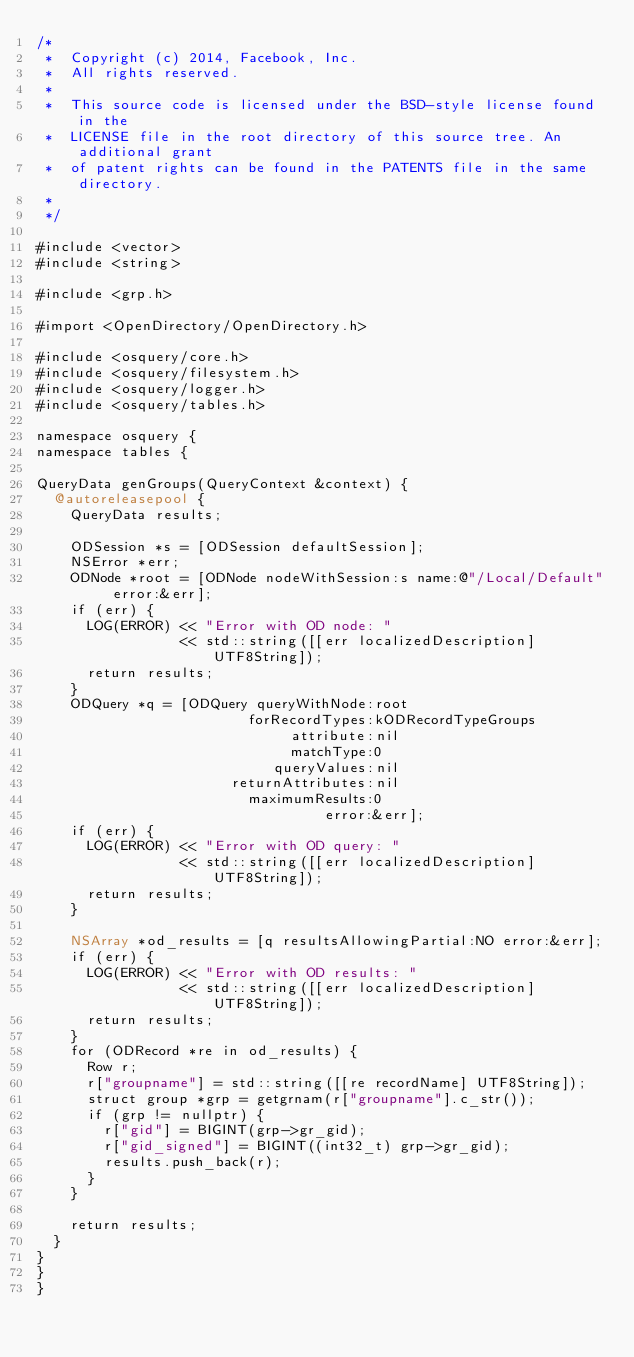Convert code to text. <code><loc_0><loc_0><loc_500><loc_500><_ObjectiveC_>/*
 *  Copyright (c) 2014, Facebook, Inc.
 *  All rights reserved.
 *
 *  This source code is licensed under the BSD-style license found in the
 *  LICENSE file in the root directory of this source tree. An additional grant 
 *  of patent rights can be found in the PATENTS file in the same directory.
 *
 */

#include <vector>
#include <string>

#include <grp.h>

#import <OpenDirectory/OpenDirectory.h>

#include <osquery/core.h>
#include <osquery/filesystem.h>
#include <osquery/logger.h>
#include <osquery/tables.h>

namespace osquery {
namespace tables {

QueryData genGroups(QueryContext &context) {
  @autoreleasepool {
    QueryData results;

    ODSession *s = [ODSession defaultSession];
    NSError *err;
    ODNode *root = [ODNode nodeWithSession:s name:@"/Local/Default" error:&err];
    if (err) {
      LOG(ERROR) << "Error with OD node: "
                 << std::string([[err localizedDescription] UTF8String]);
      return results;
    }
    ODQuery *q = [ODQuery queryWithNode:root
                         forRecordTypes:kODRecordTypeGroups
                              attribute:nil
                              matchType:0
                            queryValues:nil
                       returnAttributes:nil
                         maximumResults:0
                                  error:&err];
    if (err) {
      LOG(ERROR) << "Error with OD query: "
                 << std::string([[err localizedDescription] UTF8String]);
      return results;
    }

    NSArray *od_results = [q resultsAllowingPartial:NO error:&err];
    if (err) {
      LOG(ERROR) << "Error with OD results: "
                 << std::string([[err localizedDescription] UTF8String]);
      return results;
    }
    for (ODRecord *re in od_results) {
      Row r;
      r["groupname"] = std::string([[re recordName] UTF8String]);
      struct group *grp = getgrnam(r["groupname"].c_str());
      if (grp != nullptr) {
        r["gid"] = BIGINT(grp->gr_gid);
        r["gid_signed"] = BIGINT((int32_t) grp->gr_gid);
        results.push_back(r);
      }
    }

    return results;
  }
}
}
}
</code> 